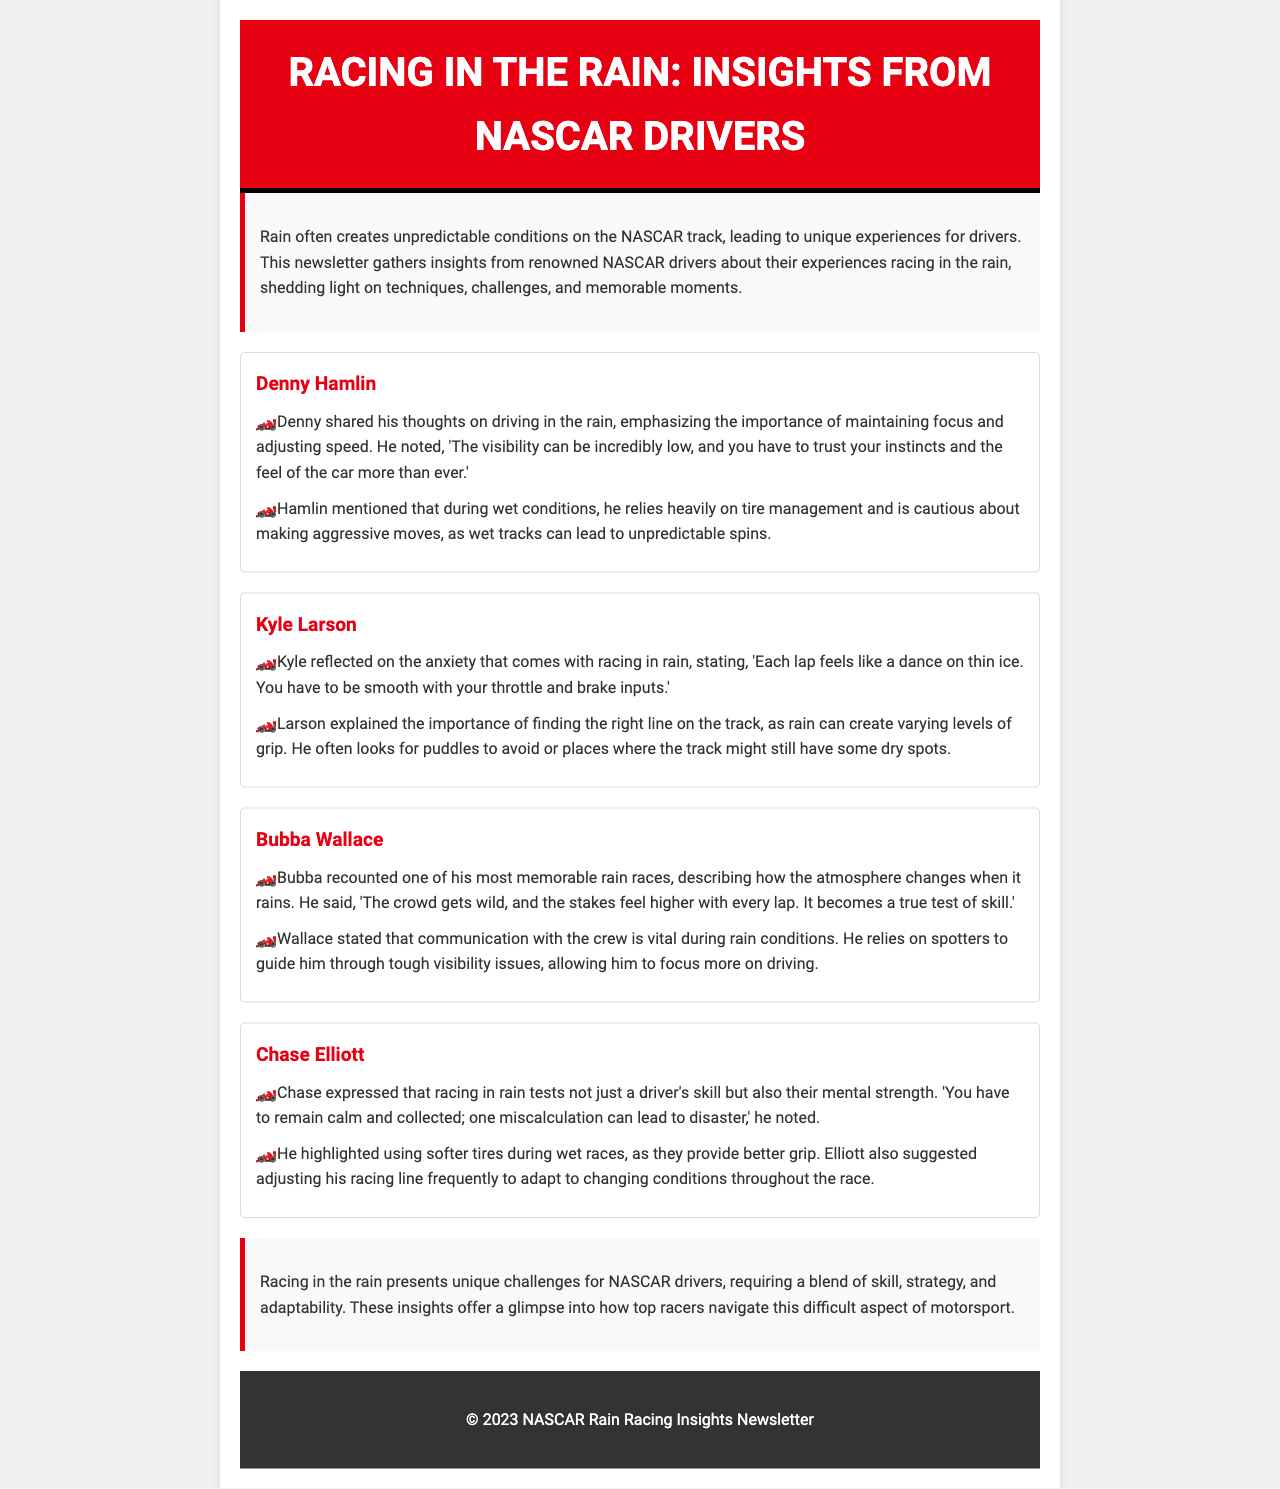What is the title of the newsletter? The title of the newsletter is clearly stated in the header section of the document.
Answer: Racing in the Rain: Insights from NASCAR Drivers Who is the first driver interviewed? The newsletter lists the drivers in order and the first one mentioned is Denny Hamlin.
Answer: Denny Hamlin What does Chase Elliott say is tested during rain racing? Elliott mentions that racing in rain tests both skill and mental strength, indicating a combination of factors is being evaluated.
Answer: skill and mental strength Which driver emphasizes tire management as a technique during rain? The driver who stresses the importance of tire management is Denny Hamlin, as per his interview section.
Answer: Denny Hamlin How does Kyle Larson describe racing in rain? His description highlights the careful balance required, where each lap feels precarious and requires smooth inputs.
Answer: a dance on thin ice What communication aspect does Bubba Wallace find vital during rain races? Wallace states that communication with the crew is essential, particularly in low visibility conditions.
Answer: communication with the crew What specific tire type does Chase Elliott suggest for wet races? Elliott highlights using softer tires during wet races, as they help improve grip on slippery tracks.
Answer: softer tires What is a common theme in Denny Hamlin and Chase Elliott's experiences in the rain? Both drivers emphasize the importance of focus and adaptation to changing conditions, which showcases the mental aspect of racing.
Answer: focus and adaptation What emotion does Bubba Wallace say is heightened during rain races? Wallace describes the atmosphere as intense, suggesting that the stakes feel significantly elevated when racing in the rain.
Answer: excitement 